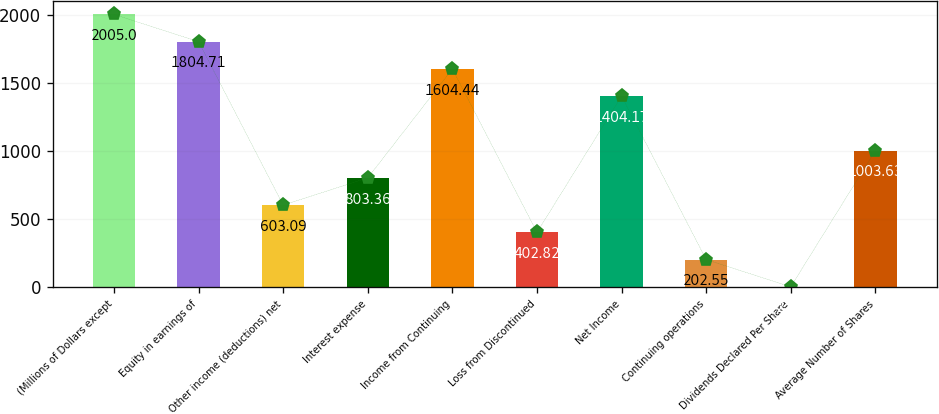<chart> <loc_0><loc_0><loc_500><loc_500><bar_chart><fcel>(Millions of Dollars except<fcel>Equity in earnings of<fcel>Other income (deductions) net<fcel>Interest expense<fcel>Income from Continuing<fcel>Loss from Discontinued<fcel>Net Income<fcel>Continuing operations<fcel>Dividends Declared Per Share<fcel>Average Number of Shares<nl><fcel>2005<fcel>1804.71<fcel>603.09<fcel>803.36<fcel>1604.44<fcel>402.82<fcel>1404.17<fcel>202.55<fcel>2.28<fcel>1003.63<nl></chart> 